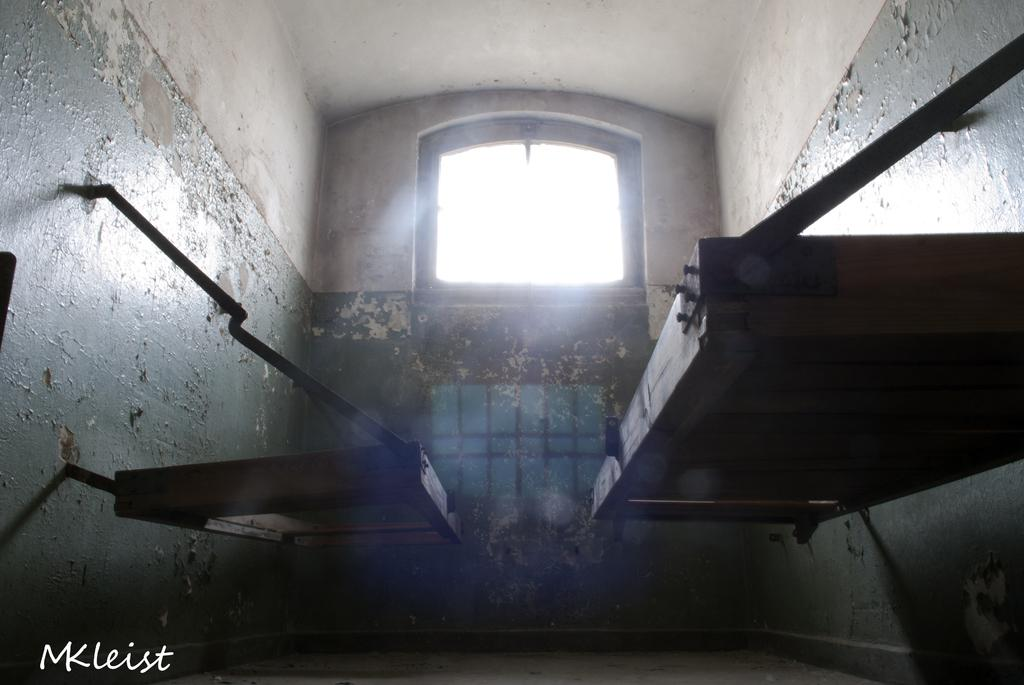What type of surface is visible in the image? The image contains a floor. What architectural feature can be seen in the image? There is a window in the image. What surrounds the floor and window? The image includes walls. What can be found within the image? There are objects present in the image. Where is the text located in the image? The text is visible at the bottom left corner of the image. What type of smell is associated with the text in the image? There is no information about the smell associated with the text in the image, as the facts provided only mention its presence and location. 